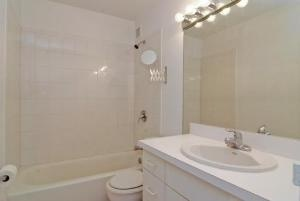Describe the objects in this image and their specific colors. I can see sink in darkgray and lightgray tones and toilet in darkgray and gray tones in this image. 